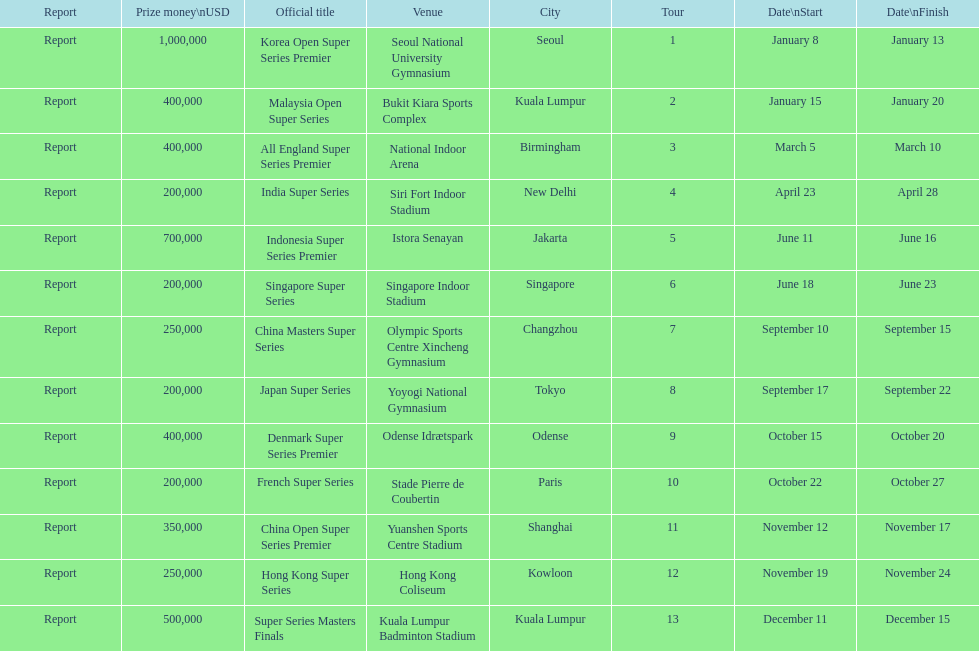Does the malaysia open super series pay more or less than french super series? More. 